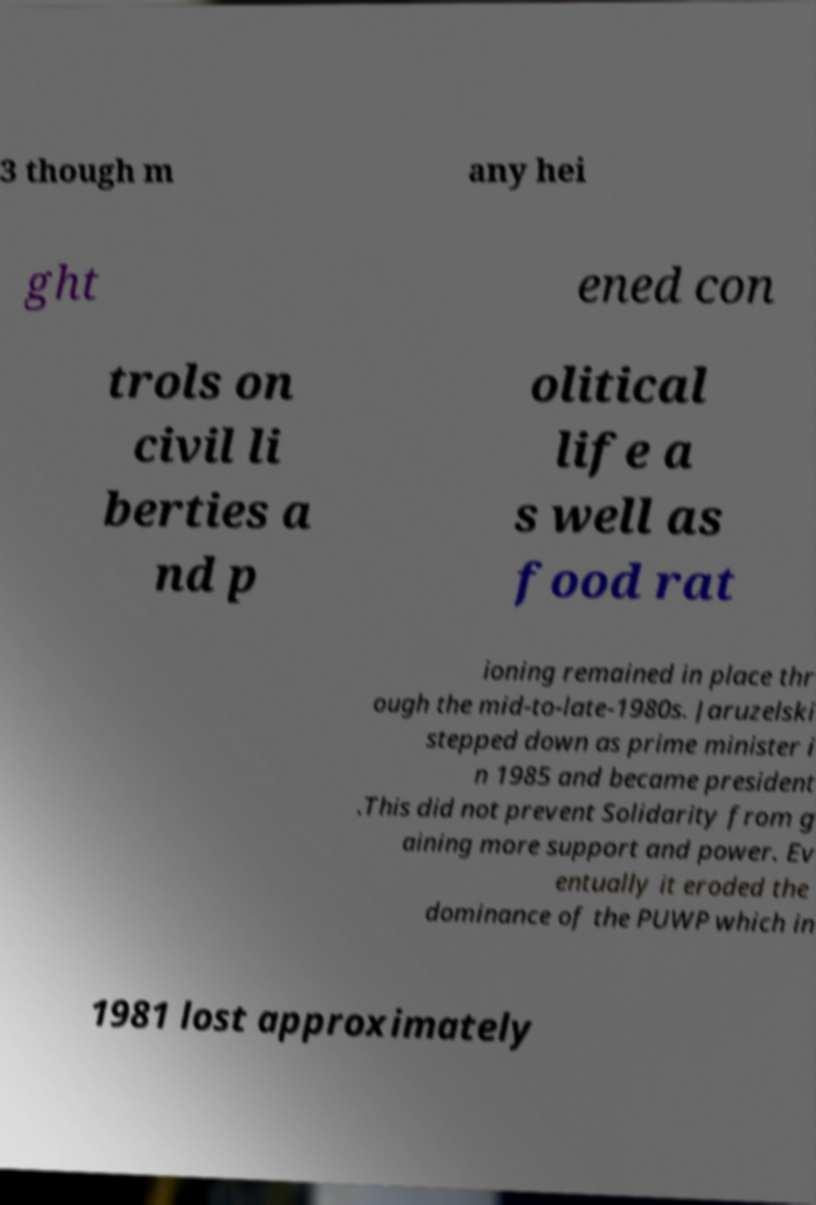I need the written content from this picture converted into text. Can you do that? 3 though m any hei ght ened con trols on civil li berties a nd p olitical life a s well as food rat ioning remained in place thr ough the mid-to-late-1980s. Jaruzelski stepped down as prime minister i n 1985 and became president .This did not prevent Solidarity from g aining more support and power. Ev entually it eroded the dominance of the PUWP which in 1981 lost approximately 